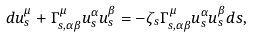Convert formula to latex. <formula><loc_0><loc_0><loc_500><loc_500>d u ^ { \mu } _ { s } + \Gamma ^ { \mu } _ { s , \alpha \beta } u ^ { \alpha } _ { s } u ^ { \beta } _ { s } = - \zeta _ { s } \Gamma ^ { \mu } _ { s , \alpha \beta } u ^ { \alpha } _ { s } u ^ { \beta } _ { s } d s ,</formula> 